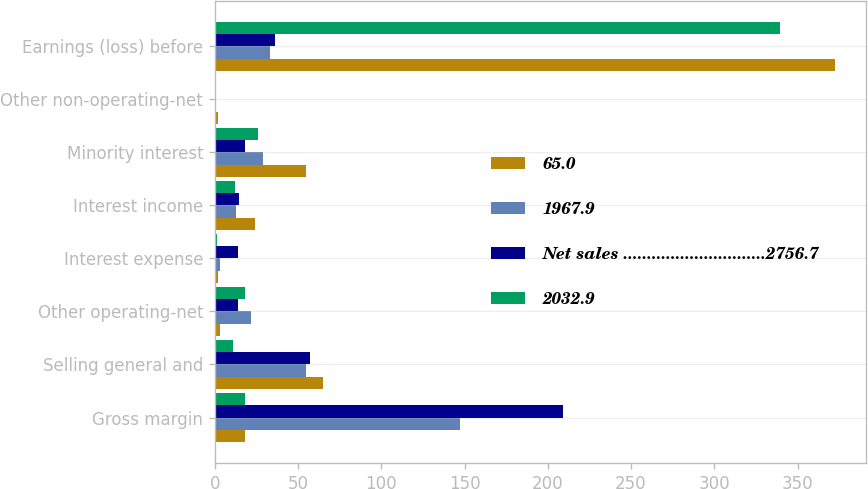Convert chart to OTSL. <chart><loc_0><loc_0><loc_500><loc_500><stacked_bar_chart><ecel><fcel>Gross margin<fcel>Selling general and<fcel>Other operating-net<fcel>Interest expense<fcel>Interest income<fcel>Minority interest<fcel>Other non-operating-net<fcel>Earnings (loss) before<nl><fcel>65.0<fcel>18<fcel>65.2<fcel>3.2<fcel>1.7<fcel>24.4<fcel>54.6<fcel>1.6<fcel>372.7<nl><fcel>1967.9<fcel>147.2<fcel>54.5<fcel>21.4<fcel>2.9<fcel>12.5<fcel>28.8<fcel>0.9<fcel>33.3<nl><fcel>Net sales ..............................2756.7<fcel>209.2<fcel>57<fcel>14.1<fcel>14<fcel>14.6<fcel>17.8<fcel>0.1<fcel>36.2<nl><fcel>2032.9<fcel>18<fcel>10.7<fcel>18.2<fcel>1.2<fcel>11.9<fcel>25.8<fcel>0.7<fcel>339.4<nl></chart> 